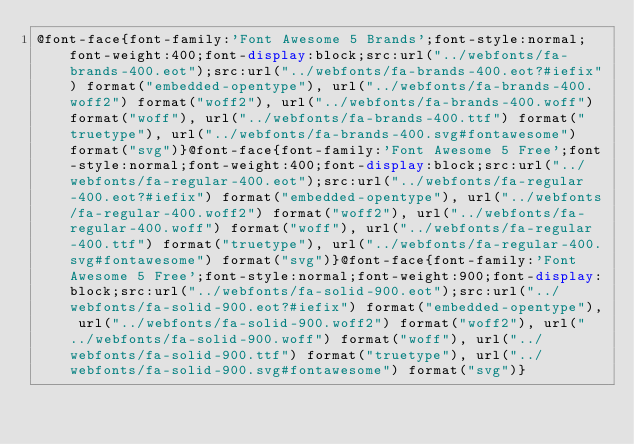<code> <loc_0><loc_0><loc_500><loc_500><_CSS_>@font-face{font-family:'Font Awesome 5 Brands';font-style:normal;font-weight:400;font-display:block;src:url("../webfonts/fa-brands-400.eot");src:url("../webfonts/fa-brands-400.eot?#iefix") format("embedded-opentype"), url("../webfonts/fa-brands-400.woff2") format("woff2"), url("../webfonts/fa-brands-400.woff") format("woff"), url("../webfonts/fa-brands-400.ttf") format("truetype"), url("../webfonts/fa-brands-400.svg#fontawesome") format("svg")}@font-face{font-family:'Font Awesome 5 Free';font-style:normal;font-weight:400;font-display:block;src:url("../webfonts/fa-regular-400.eot");src:url("../webfonts/fa-regular-400.eot?#iefix") format("embedded-opentype"), url("../webfonts/fa-regular-400.woff2") format("woff2"), url("../webfonts/fa-regular-400.woff") format("woff"), url("../webfonts/fa-regular-400.ttf") format("truetype"), url("../webfonts/fa-regular-400.svg#fontawesome") format("svg")}@font-face{font-family:'Font Awesome 5 Free';font-style:normal;font-weight:900;font-display:block;src:url("../webfonts/fa-solid-900.eot");src:url("../webfonts/fa-solid-900.eot?#iefix") format("embedded-opentype"), url("../webfonts/fa-solid-900.woff2") format("woff2"), url("../webfonts/fa-solid-900.woff") format("woff"), url("../webfonts/fa-solid-900.ttf") format("truetype"), url("../webfonts/fa-solid-900.svg#fontawesome") format("svg")}
</code> 